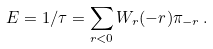Convert formula to latex. <formula><loc_0><loc_0><loc_500><loc_500>E = 1 / \tau = \sum _ { r < 0 } W _ { r } ( - r ) \pi _ { - r } \, .</formula> 